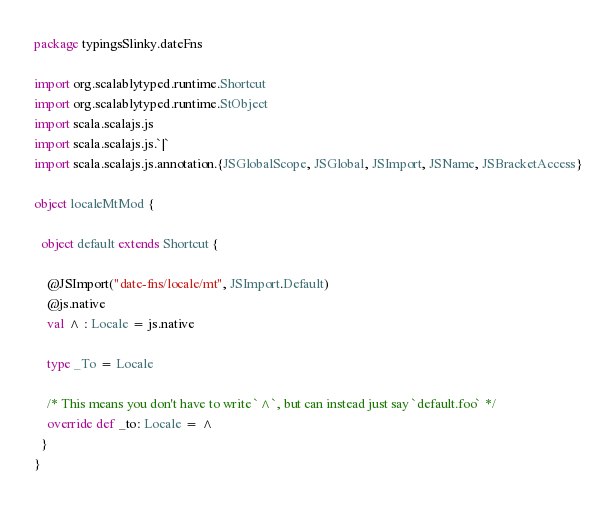Convert code to text. <code><loc_0><loc_0><loc_500><loc_500><_Scala_>package typingsSlinky.dateFns

import org.scalablytyped.runtime.Shortcut
import org.scalablytyped.runtime.StObject
import scala.scalajs.js
import scala.scalajs.js.`|`
import scala.scalajs.js.annotation.{JSGlobalScope, JSGlobal, JSImport, JSName, JSBracketAccess}

object localeMtMod {
  
  object default extends Shortcut {
    
    @JSImport("date-fns/locale/mt", JSImport.Default)
    @js.native
    val ^ : Locale = js.native
    
    type _To = Locale
    
    /* This means you don't have to write `^`, but can instead just say `default.foo` */
    override def _to: Locale = ^
  }
}
</code> 